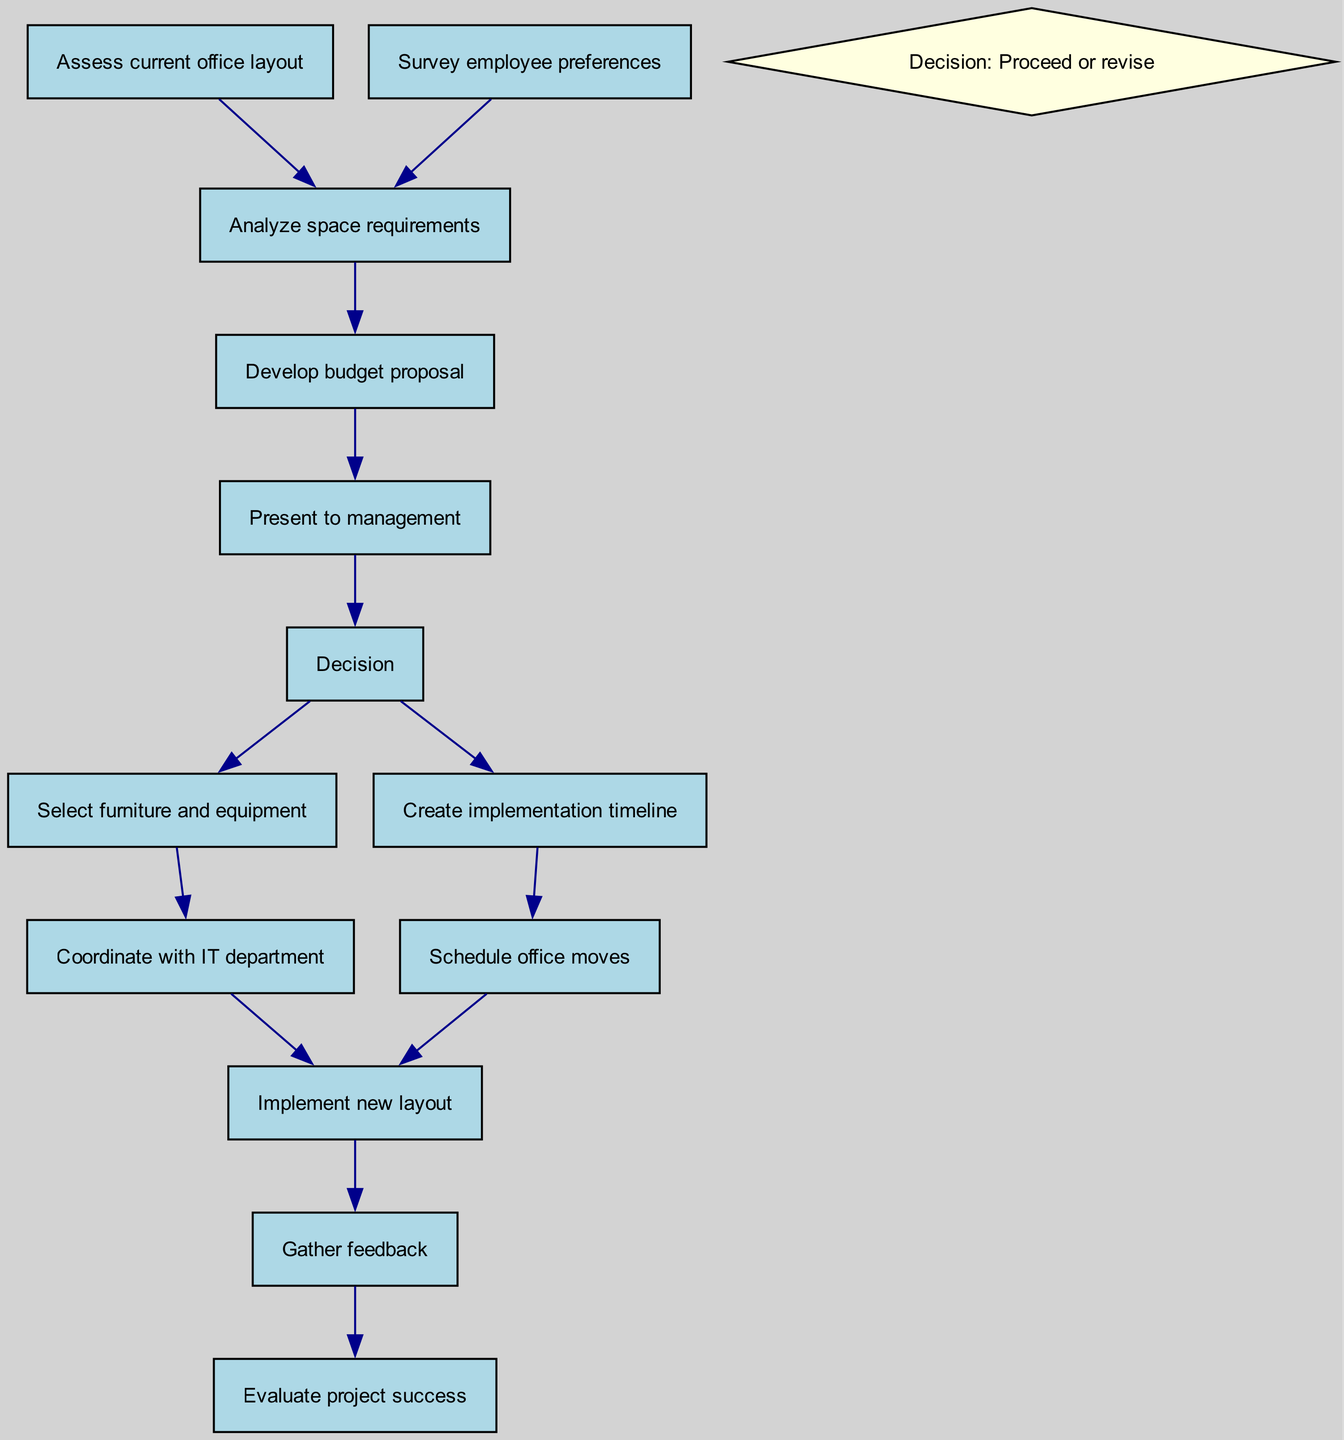What is the total number of nodes in the diagram? The diagram lists fourteen distinct tasks and decision points which can be counted directly from the nodes provided in the data.
Answer: Fourteen Which decision point follows the management presentation? According to the flow of the diagram, the decision point that comes after presenting to management is "Decision: Proceed or revise."
Answer: Decision: Proceed or revise What task directly leads to implementing the new layout? From the diagram, both "Coordinate with IT department" and "Schedule office moves" lead to "Implement new layout," indicating that either task can lead to this process.
Answer: Coordinate with IT department or Schedule office moves How many edges are there in the graph? The edges indicate the relationships between the nodes, and by counting the connections provided in the data, we find that there are thirteen.
Answer: Thirteen What comes after gathering feedback? Following the "Gather feedback" task, the next step is to "Evaluate project success," which completes the workflow as shown in the directed graph.
Answer: Evaluate project success Which node has the most dependencies leading to it? Analyzing the flow directives, "Analyze space requirements" has two preceding tasks, namely "Assess current office layout" and "Survey employee preferences," making it the node with the most dependencies.
Answer: Analyze space requirements What type of shape is used for decision points in the diagram? The decision points in the diagram are represented by diamond shapes, which are commonly used to signify decisions in a flowchart.
Answer: Diamond Which tasks lead to creating an implementation timeline? The task "Create implementation timeline" is directly derived from the decision point "Decision: Proceed or revise," indicating that this action stems from the decision-making process.
Answer: Decision: Proceed or revise 